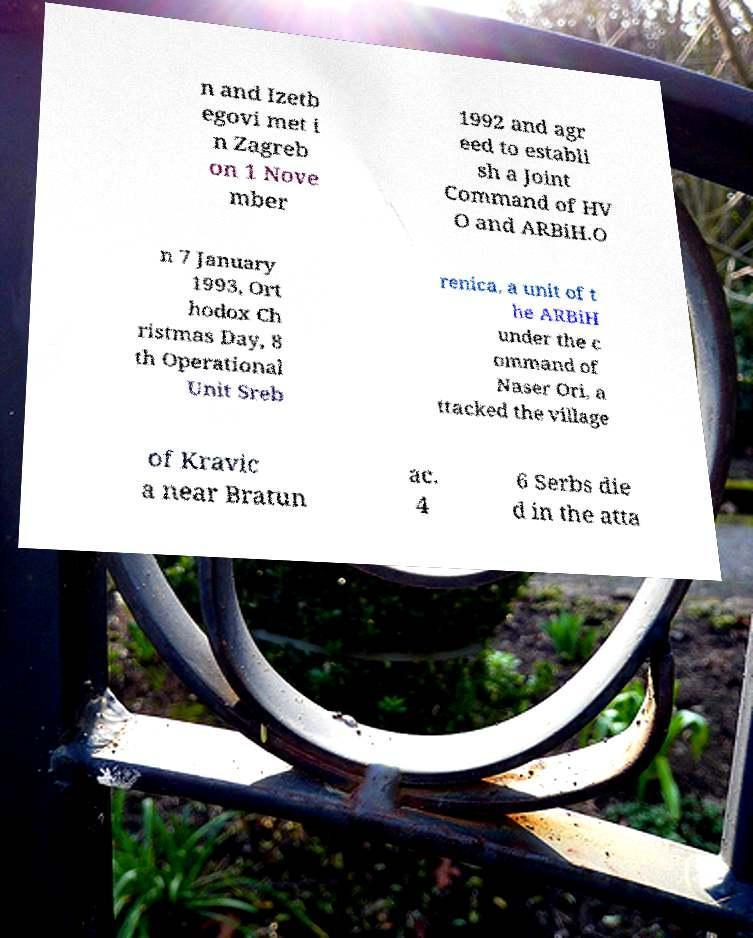Could you assist in decoding the text presented in this image and type it out clearly? n and Izetb egovi met i n Zagreb on 1 Nove mber 1992 and agr eed to establi sh a Joint Command of HV O and ARBiH.O n 7 January 1993, Ort hodox Ch ristmas Day, 8 th Operational Unit Sreb renica, a unit of t he ARBiH under the c ommand of Naser Ori, a ttacked the village of Kravic a near Bratun ac. 4 6 Serbs die d in the atta 